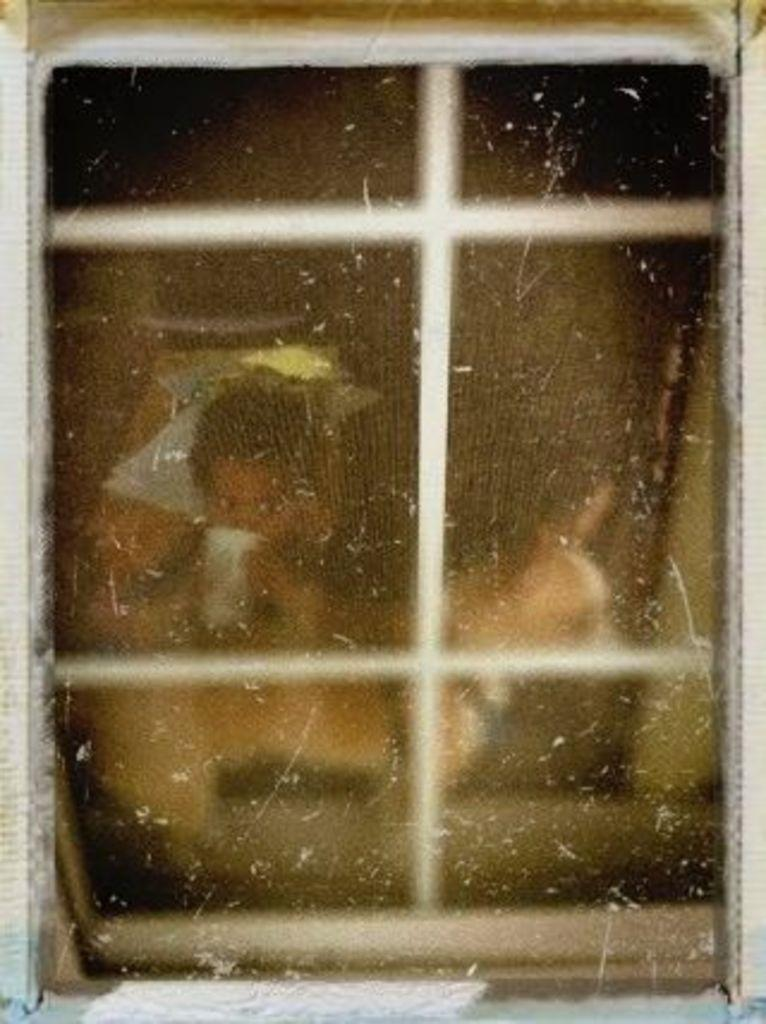What is present in the image that allows us to see outside? There is a window in the image. Can you describe the person in the background of the image? The person in the background is holding a glass. What type of sweater is the person wearing in the image? There is no information about the person's clothing in the image, so we cannot determine if they are wearing a sweater or any other type of clothing. 